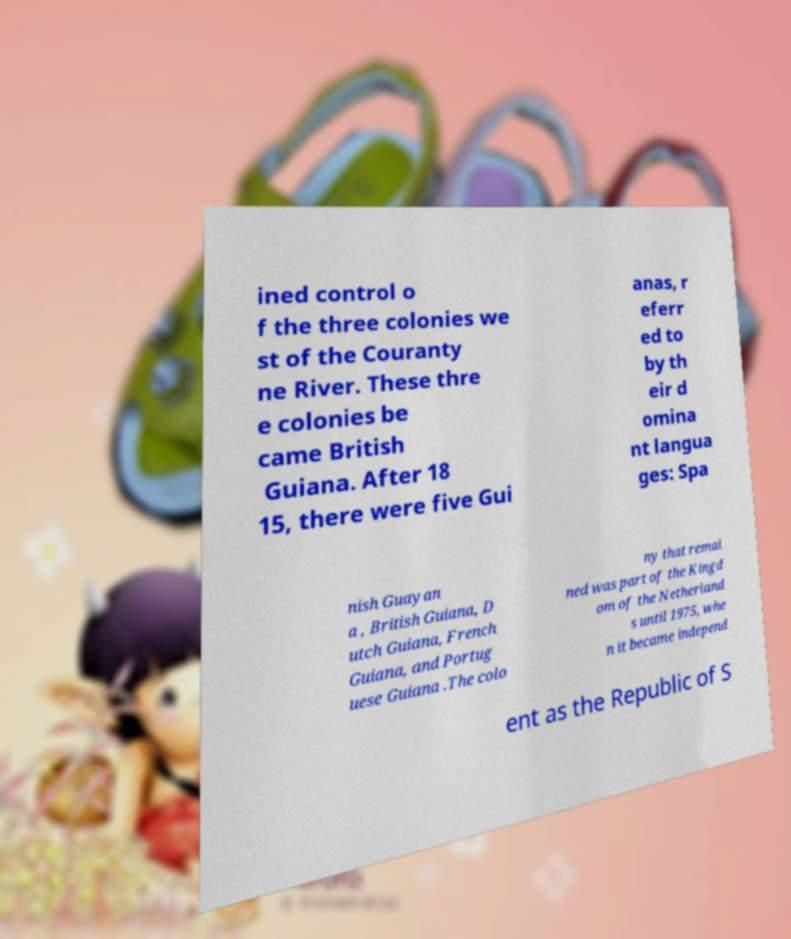Can you read and provide the text displayed in the image?This photo seems to have some interesting text. Can you extract and type it out for me? ined control o f the three colonies we st of the Couranty ne River. These thre e colonies be came British Guiana. After 18 15, there were five Gui anas, r eferr ed to by th eir d omina nt langua ges: Spa nish Guayan a , British Guiana, D utch Guiana, French Guiana, and Portug uese Guiana .The colo ny that remai ned was part of the Kingd om of the Netherland s until 1975, whe n it became independ ent as the Republic of S 